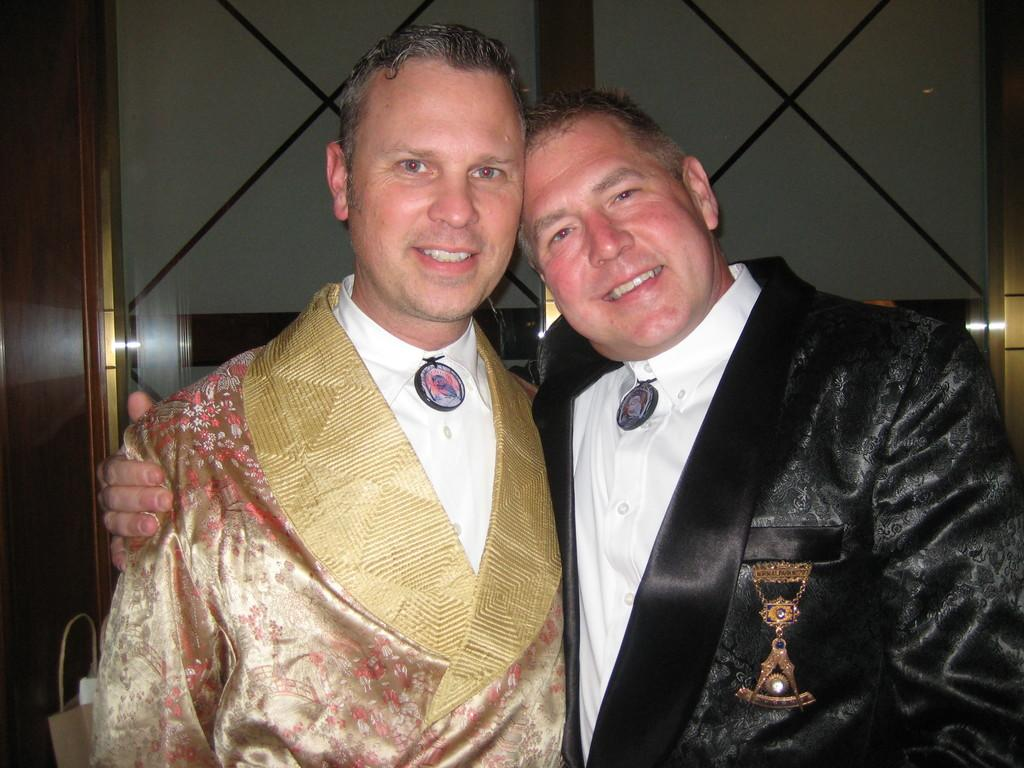How many people are in the image? There are two men in the picture. What are the men doing in the image? The men are standing together and smiling. What can be inferred about the men's mood from their expressions? The men are smiling, which suggests they are in a positive or happy mood. What are the men wearing in the image? The men are wearing clothes. What is visible in the background of the image? There is a framed glass wall in the background of the image. What type of noise can be heard coming from the beds in the image? There are no beds present in the image, so it is not possible to determine what, if any, noise might be heard. 